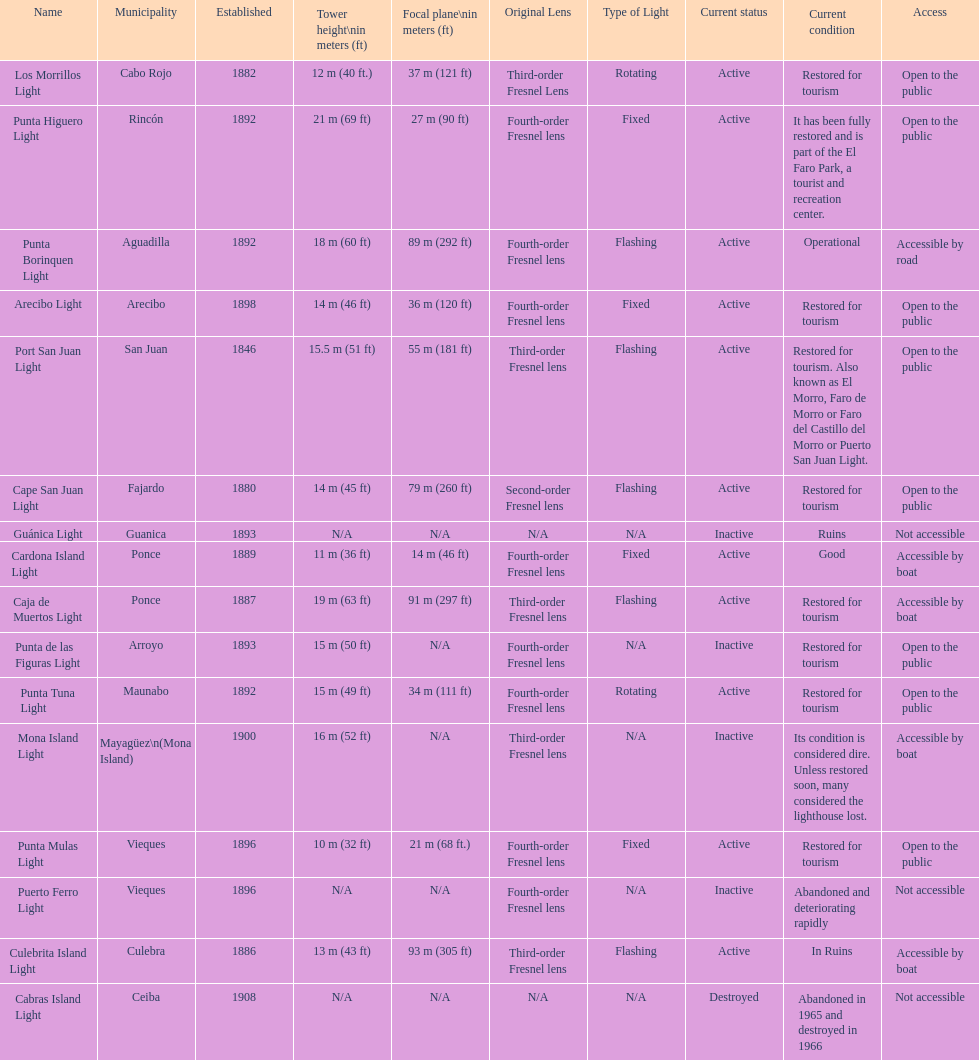The difference in years from 1882 to 1889 7. 